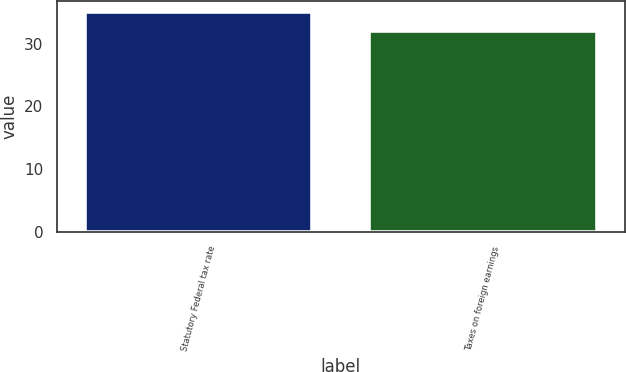Convert chart. <chart><loc_0><loc_0><loc_500><loc_500><bar_chart><fcel>Statutory Federal tax rate<fcel>Taxes on foreign earnings<nl><fcel>35<fcel>32<nl></chart> 